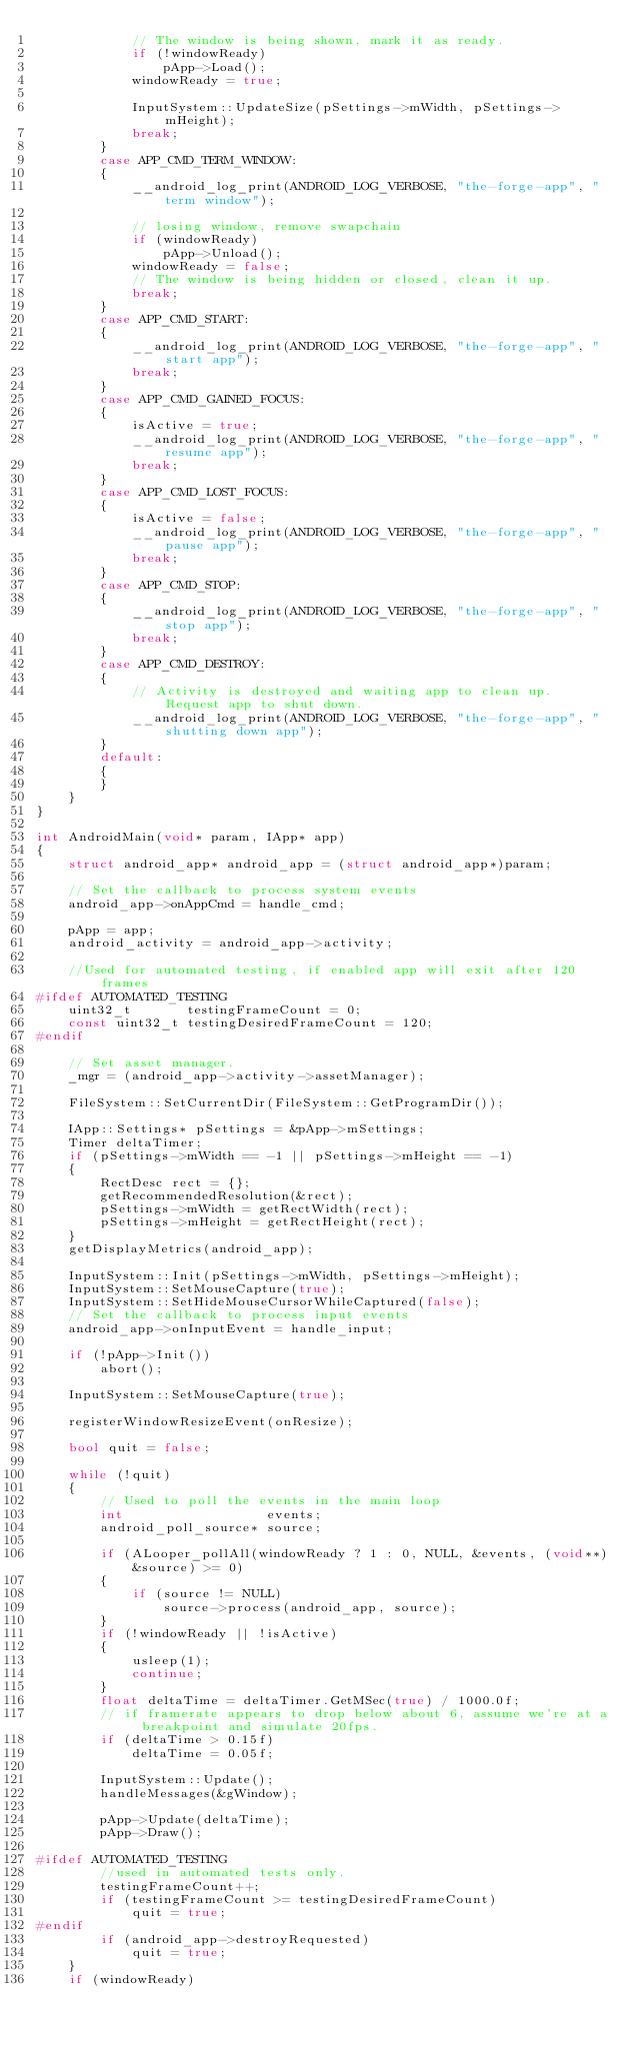<code> <loc_0><loc_0><loc_500><loc_500><_C++_>			// The window is being shown, mark it as ready.
			if (!windowReady)
				pApp->Load();
			windowReady = true;

			InputSystem::UpdateSize(pSettings->mWidth, pSettings->mHeight);
			break;
		}
		case APP_CMD_TERM_WINDOW:
		{
			__android_log_print(ANDROID_LOG_VERBOSE, "the-forge-app", "term window");

			// losing window, remove swapchain
			if (windowReady)
				pApp->Unload();
			windowReady = false;
			// The window is being hidden or closed, clean it up.
			break;
		}
		case APP_CMD_START:
		{
			__android_log_print(ANDROID_LOG_VERBOSE, "the-forge-app", "start app");
			break;
		}
		case APP_CMD_GAINED_FOCUS:
		{
			isActive = true;
			__android_log_print(ANDROID_LOG_VERBOSE, "the-forge-app", "resume app");
			break;
		}
		case APP_CMD_LOST_FOCUS:
		{
			isActive = false;
			__android_log_print(ANDROID_LOG_VERBOSE, "the-forge-app", "pause app");
			break;
		}
		case APP_CMD_STOP:
		{
			__android_log_print(ANDROID_LOG_VERBOSE, "the-forge-app", "stop app");
			break;
		}
		case APP_CMD_DESTROY:
		{
			// Activity is destroyed and waiting app to clean up. Request app to shut down.
			__android_log_print(ANDROID_LOG_VERBOSE, "the-forge-app", "shutting down app");
		}
		default:
		{
		}
	}
}

int AndroidMain(void* param, IApp* app)
{
	struct android_app* android_app = (struct android_app*)param;

	// Set the callback to process system events
    android_app->onAppCmd = handle_cmd;

	pApp = app;
	android_activity = android_app->activity;

	//Used for automated testing, if enabled app will exit after 120 frames
#ifdef AUTOMATED_TESTING
	uint32_t       testingFrameCount = 0;
	const uint32_t testingDesiredFrameCount = 120;
#endif

	// Set asset manager.
	_mgr = (android_app->activity->assetManager);

	FileSystem::SetCurrentDir(FileSystem::GetProgramDir());

	IApp::Settings* pSettings = &pApp->mSettings;
	Timer deltaTimer;
	if (pSettings->mWidth == -1 || pSettings->mHeight == -1)
	{
		RectDesc rect = {};
		getRecommendedResolution(&rect);
		pSettings->mWidth = getRectWidth(rect);
		pSettings->mHeight = getRectHeight(rect);
	}
	getDisplayMetrics(android_app);

	InputSystem::Init(pSettings->mWidth, pSettings->mHeight);
    InputSystem::SetMouseCapture(true);
    InputSystem::SetHideMouseCursorWhileCaptured(false);
	// Set the callback to process input events
    android_app->onInputEvent = handle_input;

	if (!pApp->Init())
		abort();

	InputSystem::SetMouseCapture(true);

	registerWindowResizeEvent(onResize);

	bool quit = false;

	while (!quit)
	{
		// Used to poll the events in the main loop
		int                  events;
		android_poll_source* source;

		if (ALooper_pollAll(windowReady ? 1 : 0, NULL, &events, (void**)&source) >= 0)
		{
			if (source != NULL)
				source->process(android_app, source);
		}
		if (!windowReady || !isActive)
		{
			usleep(1);
			continue;
		}
		float deltaTime = deltaTimer.GetMSec(true) / 1000.0f;
		// if framerate appears to drop below about 6, assume we're at a breakpoint and simulate 20fps.
		if (deltaTime > 0.15f)
			deltaTime = 0.05f;

		InputSystem::Update();
		handleMessages(&gWindow);

		pApp->Update(deltaTime);
		pApp->Draw();

#ifdef AUTOMATED_TESTING
		//used in automated tests only.
		testingFrameCount++;
		if (testingFrameCount >= testingDesiredFrameCount)
			quit = true;
#endif
		if (android_app->destroyRequested)
			quit = true;
	}
	if (windowReady)</code> 